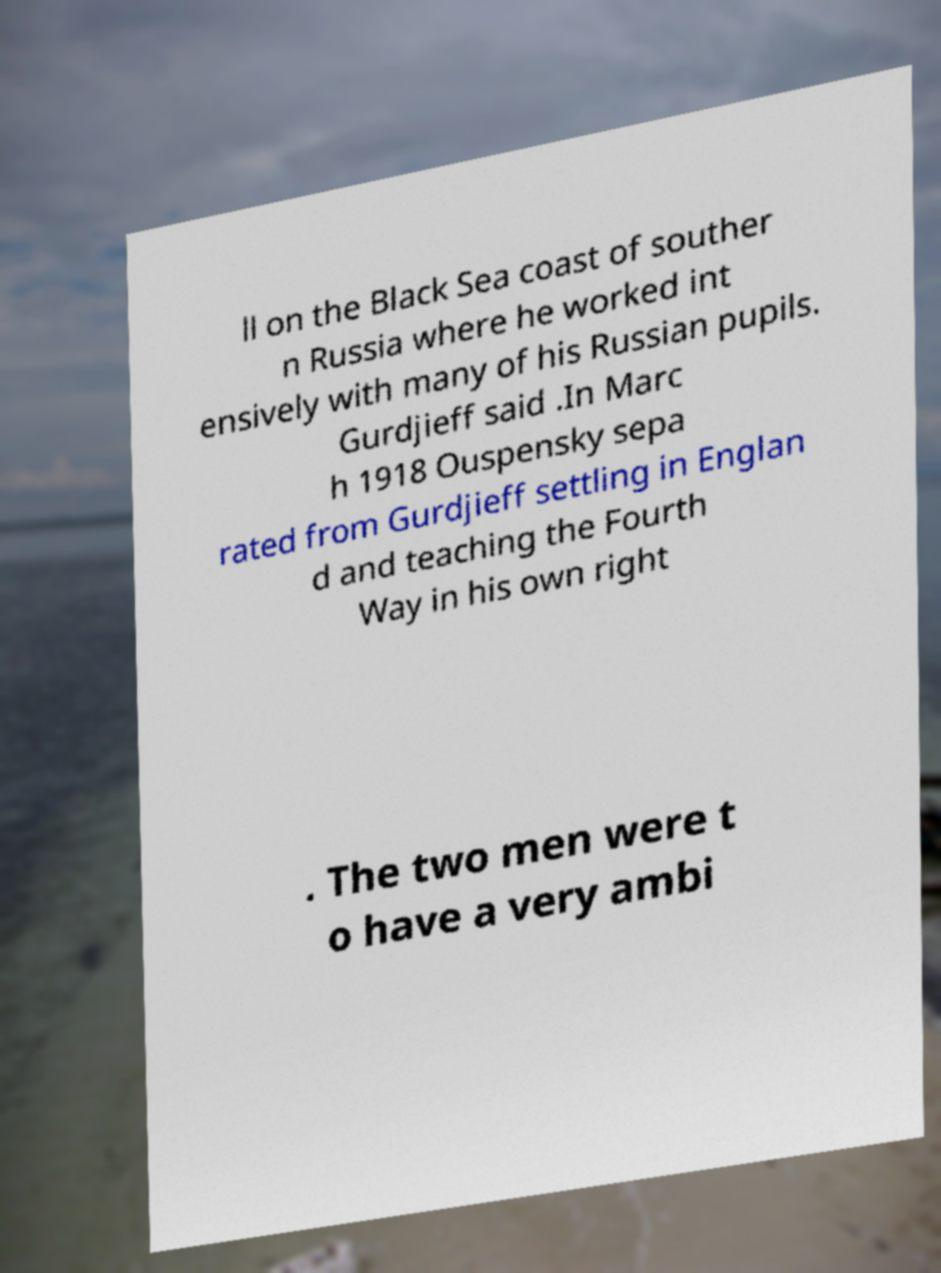Could you extract and type out the text from this image? ll on the Black Sea coast of souther n Russia where he worked int ensively with many of his Russian pupils. Gurdjieff said .In Marc h 1918 Ouspensky sepa rated from Gurdjieff settling in Englan d and teaching the Fourth Way in his own right . The two men were t o have a very ambi 